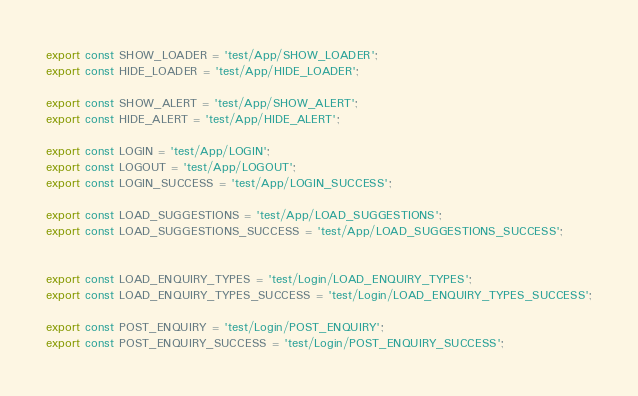<code> <loc_0><loc_0><loc_500><loc_500><_JavaScript_>export const SHOW_LOADER = 'test/App/SHOW_LOADER';
export const HIDE_LOADER = 'test/App/HIDE_LOADER';

export const SHOW_ALERT = 'test/App/SHOW_ALERT';
export const HIDE_ALERT = 'test/App/HIDE_ALERT';

export const LOGIN = 'test/App/LOGIN';
export const LOGOUT = 'test/App/LOGOUT';
export const LOGIN_SUCCESS = 'test/App/LOGIN_SUCCESS';

export const LOAD_SUGGESTIONS = 'test/App/LOAD_SUGGESTIONS';
export const LOAD_SUGGESTIONS_SUCCESS = 'test/App/LOAD_SUGGESTIONS_SUCCESS';


export const LOAD_ENQUIRY_TYPES = 'test/Login/LOAD_ENQUIRY_TYPES';
export const LOAD_ENQUIRY_TYPES_SUCCESS = 'test/Login/LOAD_ENQUIRY_TYPES_SUCCESS';

export const POST_ENQUIRY = 'test/Login/POST_ENQUIRY';
export const POST_ENQUIRY_SUCCESS = 'test/Login/POST_ENQUIRY_SUCCESS';

</code> 